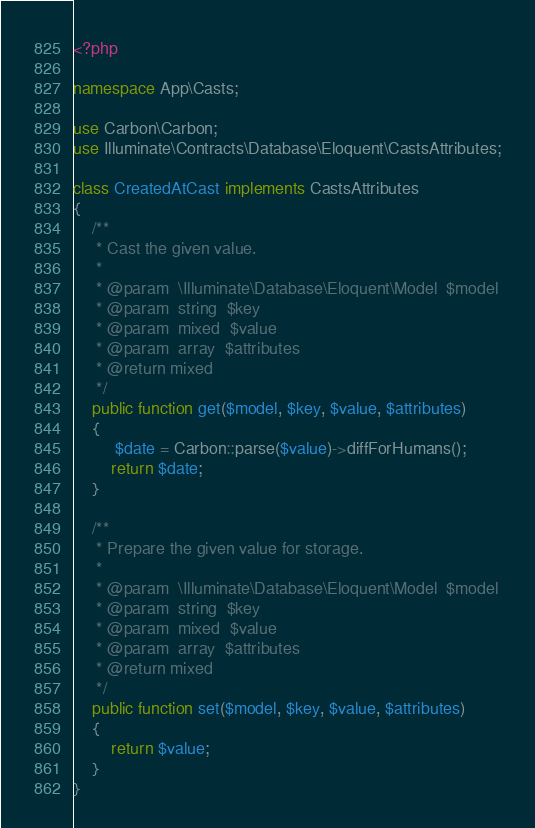Convert code to text. <code><loc_0><loc_0><loc_500><loc_500><_PHP_><?php

namespace App\Casts;

use Carbon\Carbon;
use Illuminate\Contracts\Database\Eloquent\CastsAttributes;

class CreatedAtCast implements CastsAttributes
{
    /**
     * Cast the given value.
     *
     * @param  \Illuminate\Database\Eloquent\Model  $model
     * @param  string  $key
     * @param  mixed  $value
     * @param  array  $attributes
     * @return mixed
     */
    public function get($model, $key, $value, $attributes)
    {
         $date = Carbon::parse($value)->diffForHumans();
        return $date;
    }

    /**
     * Prepare the given value for storage.
     *
     * @param  \Illuminate\Database\Eloquent\Model  $model
     * @param  string  $key
     * @param  mixed  $value
     * @param  array  $attributes
     * @return mixed
     */
    public function set($model, $key, $value, $attributes)
    {
        return $value;
    }
}
</code> 